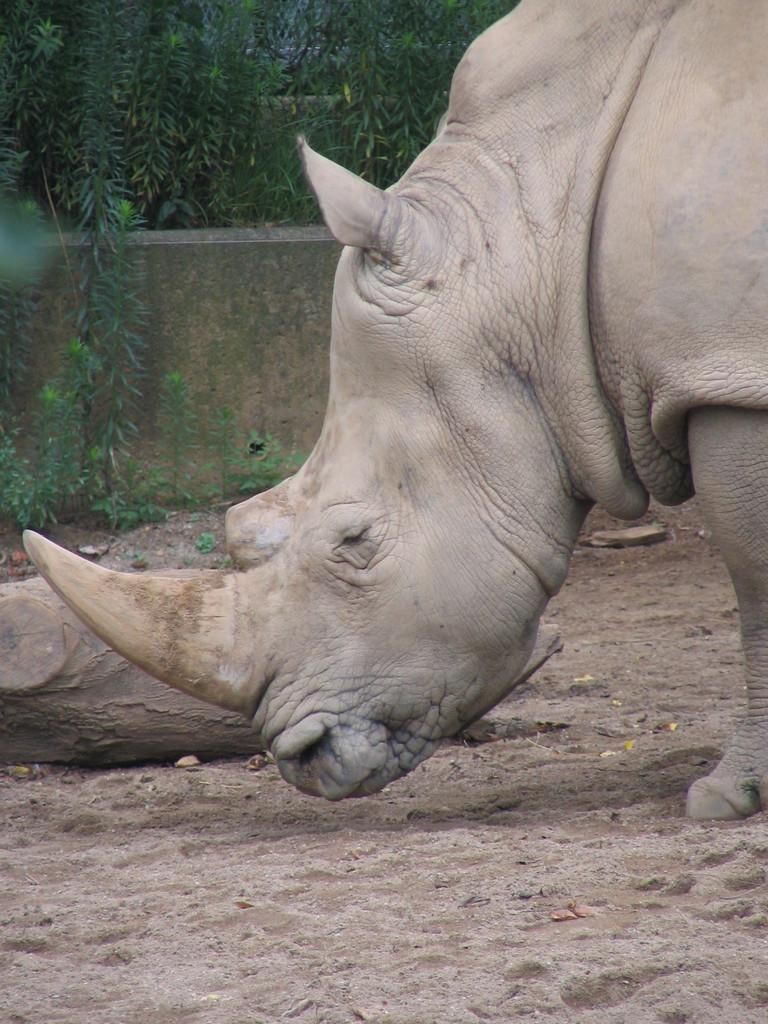What animal can be seen on the right side of the image? There is a rhinoceros on the right side of the image. What type of surface is at the bottom of the image? There is soil at the bottom of the image. What material is present in the middle of the image? There is wood in the middle of the image. What type of vegetation can be seen in the background of the image? There are plants in the background of the image. What type of temper does the doll have in the image? There is no doll present in the image, so it is not possible to determine its temper. 